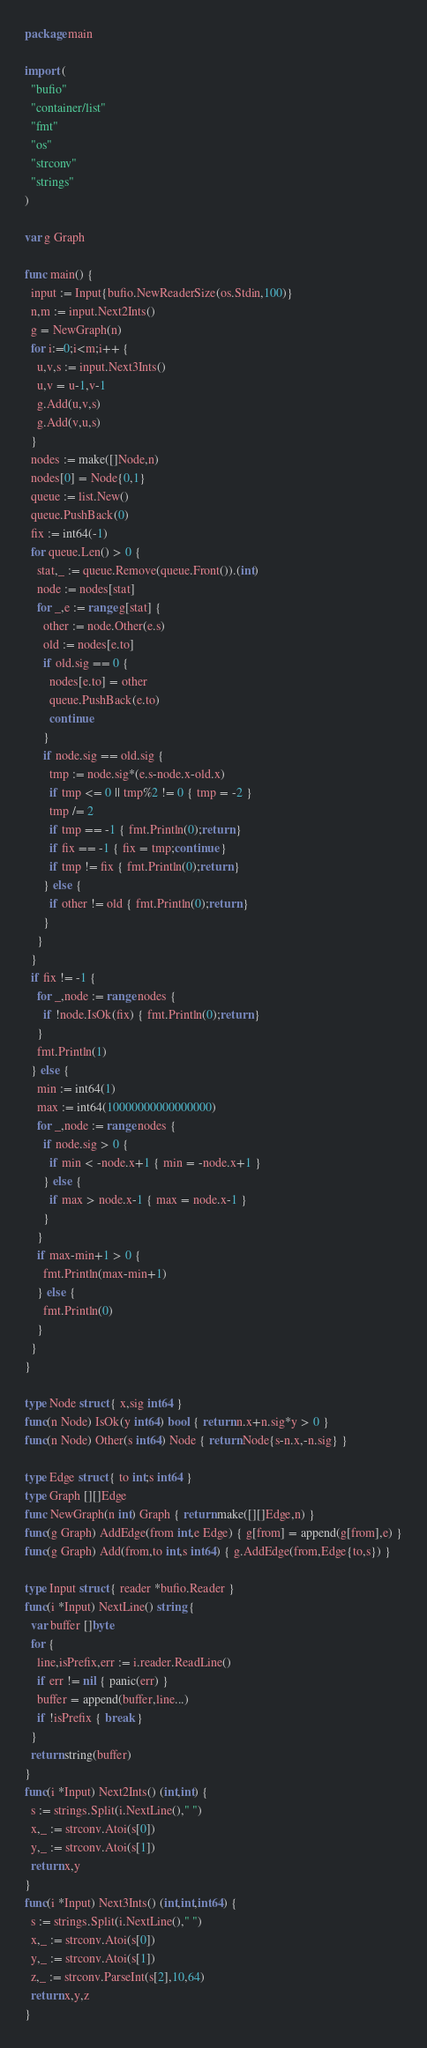Convert code to text. <code><loc_0><loc_0><loc_500><loc_500><_Go_>package main

import (
  "bufio"
  "container/list"
  "fmt"
  "os"
  "strconv"
  "strings"
)

var g Graph

func main() {
  input := Input{bufio.NewReaderSize(os.Stdin,100)}
  n,m := input.Next2Ints()
  g = NewGraph(n)
  for i:=0;i<m;i++ {
    u,v,s := input.Next3Ints()
    u,v = u-1,v-1
    g.Add(u,v,s)
    g.Add(v,u,s)
  }
  nodes := make([]Node,n)
  nodes[0] = Node{0,1}
  queue := list.New()
  queue.PushBack(0)
  fix := int64(-1)
  for queue.Len() > 0 {
    stat,_ := queue.Remove(queue.Front()).(int)
    node := nodes[stat]
    for _,e := range g[stat] {
      other := node.Other(e.s)
      old := nodes[e.to]
      if old.sig == 0 {
        nodes[e.to] = other
        queue.PushBack(e.to)
        continue
      }
      if node.sig == old.sig {
        tmp := node.sig*(e.s-node.x-old.x)
        if tmp <= 0 || tmp%2 != 0 { tmp = -2 }
        tmp /= 2
        if tmp == -1 { fmt.Println(0);return }
        if fix == -1 { fix = tmp;continue }
        if tmp != fix { fmt.Println(0);return }
      } else {
        if other != old { fmt.Println(0);return }
      }
    }
  }
  if fix != -1 {
    for _,node := range nodes {
      if !node.IsOk(fix) { fmt.Println(0);return }
    }
    fmt.Println(1)
  } else {
    min := int64(1)
    max := int64(10000000000000000)
    for _,node := range nodes {
      if node.sig > 0 {
        if min < -node.x+1 { min = -node.x+1 }
      } else {
        if max > node.x-1 { max = node.x-1 }
      }
    }
    if max-min+1 > 0 {
      fmt.Println(max-min+1)
    } else {
      fmt.Println(0)
    }
  }
}

type Node struct { x,sig int64 }
func(n Node) IsOk(y int64) bool { return n.x+n.sig*y > 0 }
func(n Node) Other(s int64) Node { return Node{s-n.x,-n.sig} }

type Edge struct { to int;s int64 }
type Graph [][]Edge
func NewGraph(n int) Graph { return make([][]Edge,n) }
func(g Graph) AddEdge(from int,e Edge) { g[from] = append(g[from],e) }
func(g Graph) Add(from,to int,s int64) { g.AddEdge(from,Edge{to,s}) }

type Input struct { reader *bufio.Reader }
func(i *Input) NextLine() string {
  var buffer []byte
  for {
    line,isPrefix,err := i.reader.ReadLine()
    if err != nil { panic(err) }
    buffer = append(buffer,line...)
    if !isPrefix { break }
  }
  return string(buffer)
}
func(i *Input) Next2Ints() (int,int) {
  s := strings.Split(i.NextLine()," ")
  x,_ := strconv.Atoi(s[0])
  y,_ := strconv.Atoi(s[1])
  return x,y
}
func(i *Input) Next3Ints() (int,int,int64) {
  s := strings.Split(i.NextLine()," ")
  x,_ := strconv.Atoi(s[0])
  y,_ := strconv.Atoi(s[1])
  z,_ := strconv.ParseInt(s[2],10,64)
  return x,y,z
}</code> 